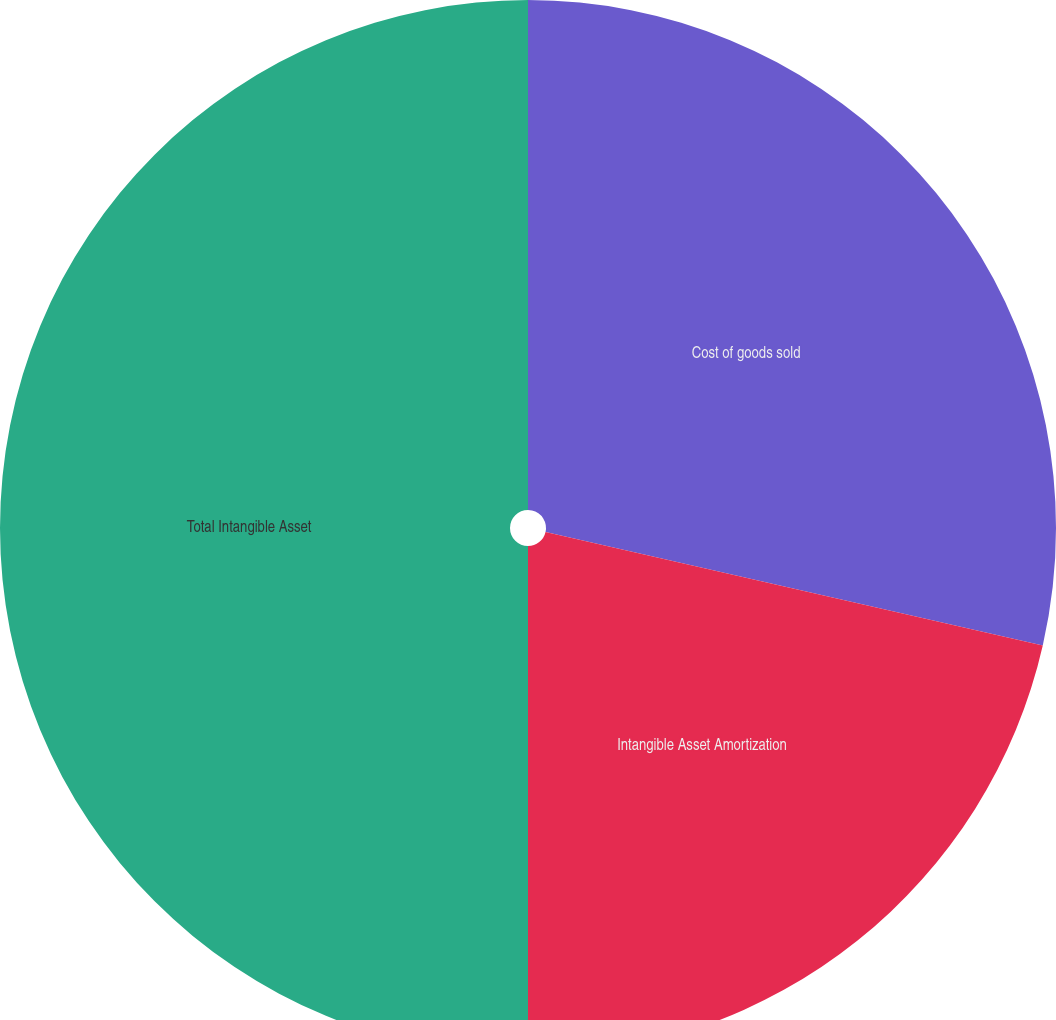Convert chart. <chart><loc_0><loc_0><loc_500><loc_500><pie_chart><fcel>Cost of goods sold<fcel>Intangible Asset Amortization<fcel>Total Intangible Asset<nl><fcel>28.57%<fcel>21.43%<fcel>50.0%<nl></chart> 